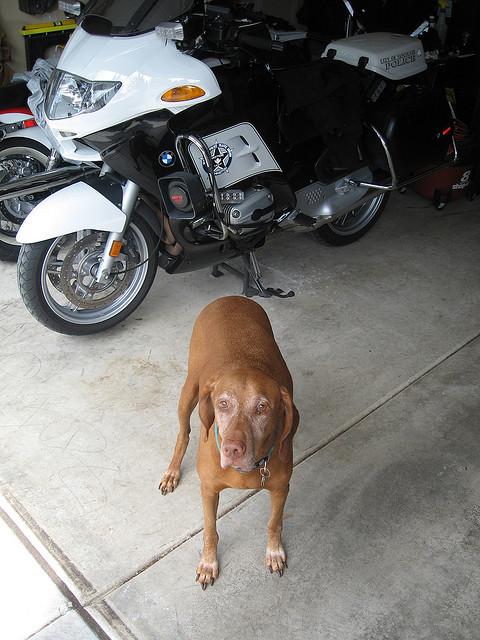Who is the dog looking at?
Concise answer only. Photographer. What kind of dog?
Quick response, please. Lab. Are there cars in the photo?
Be succinct. No. What color is the dog?
Give a very brief answer. Brown. Is the dog holding a frisbee in it's mouth?
Concise answer only. No. 